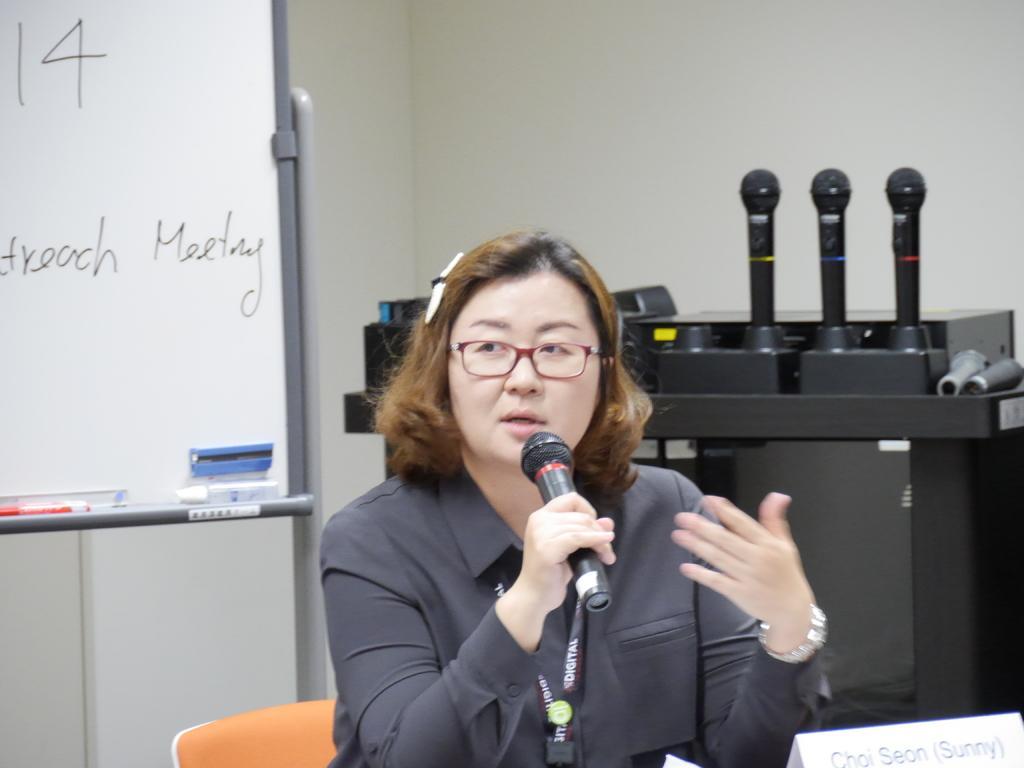How would you summarize this image in a sentence or two? In this image I can see a woman wearing a shirt, sitting on the chair and holding a mike in her hand. In the background there is a wall. On the left side of the image I can see a board. On the right side of the image there is a table and three mikes are placed on it. 